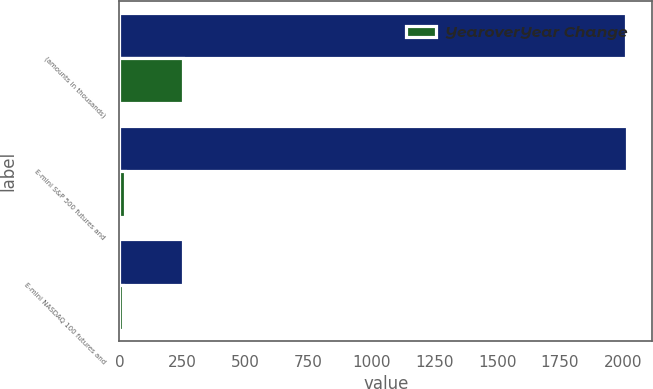<chart> <loc_0><loc_0><loc_500><loc_500><stacked_bar_chart><ecel><fcel>(amounts in thousands)<fcel>E-mini S&P 500 futures and<fcel>E-mini NASDAQ 100 futures and<nl><fcel>nan<fcel>2012<fcel>2016<fcel>254<nl><fcel>YearoverYear Change<fcel>254<fcel>23<fcel>16<nl></chart> 